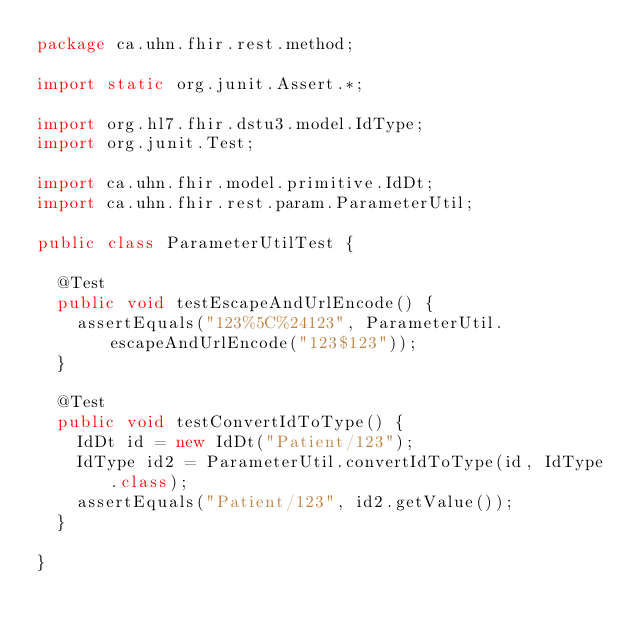Convert code to text. <code><loc_0><loc_0><loc_500><loc_500><_Java_>package ca.uhn.fhir.rest.method;

import static org.junit.Assert.*;

import org.hl7.fhir.dstu3.model.IdType;
import org.junit.Test;

import ca.uhn.fhir.model.primitive.IdDt;
import ca.uhn.fhir.rest.param.ParameterUtil;

public class ParameterUtilTest {

	@Test
	public void testEscapeAndUrlEncode() {
		assertEquals("123%5C%24123", ParameterUtil.escapeAndUrlEncode("123$123"));
	}

	@Test
	public void testConvertIdToType() {
		IdDt id = new IdDt("Patient/123");
		IdType id2 = ParameterUtil.convertIdToType(id, IdType.class);
		assertEquals("Patient/123", id2.getValue());
	}
	
}
</code> 